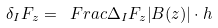<formula> <loc_0><loc_0><loc_500><loc_500>\delta _ { I } F _ { z } = \ F r a c { \Delta _ { I } F _ { z } } { \left | B ( z ) \right | \cdot h }</formula> 